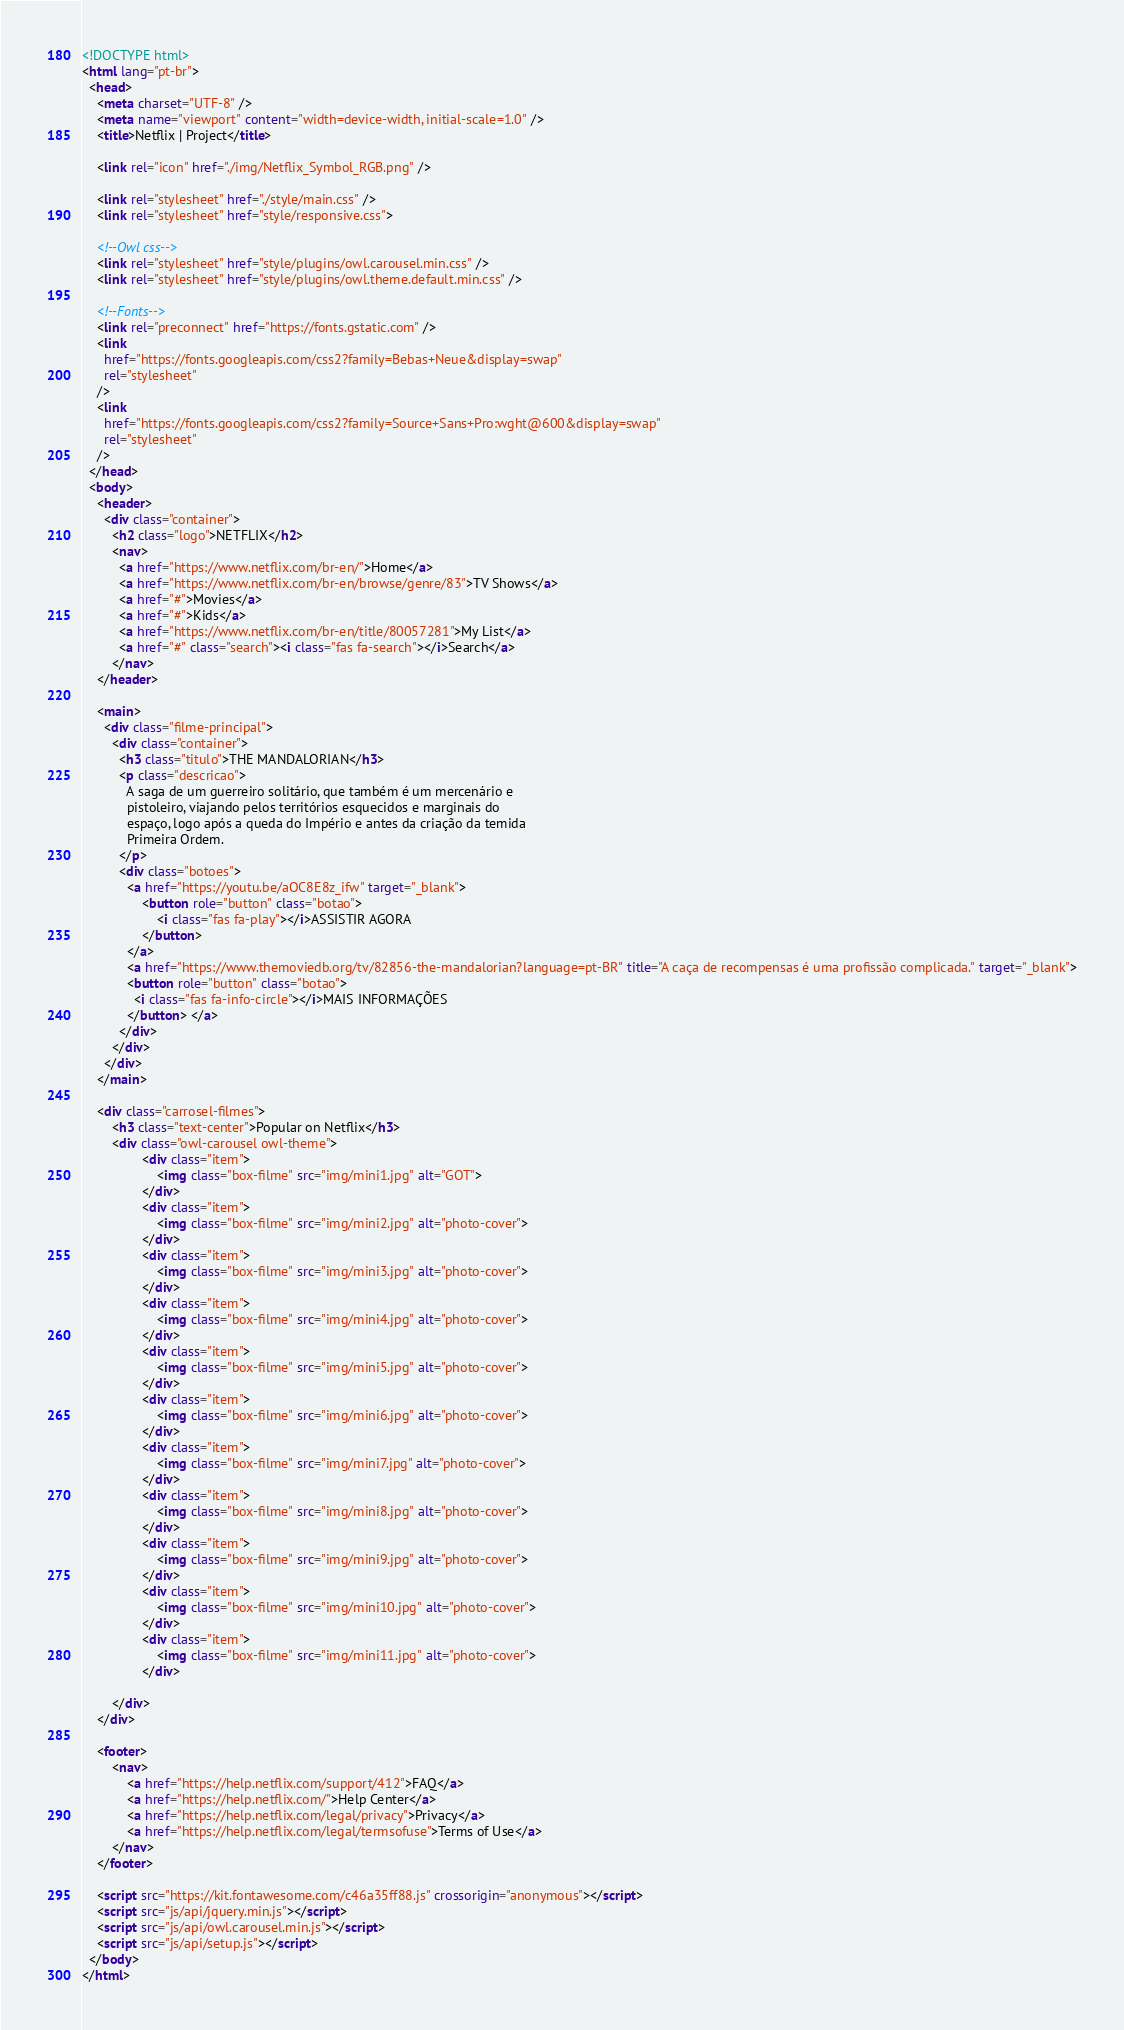Convert code to text. <code><loc_0><loc_0><loc_500><loc_500><_HTML_><!DOCTYPE html>
<html lang="pt-br">
  <head>
    <meta charset="UTF-8" />
    <meta name="viewport" content="width=device-width, initial-scale=1.0" />
    <title>Netflix | Project</title>

    <link rel="icon" href="./img/Netflix_Symbol_RGB.png" />

    <link rel="stylesheet" href="./style/main.css" />
    <link rel="stylesheet" href="style/responsive.css">

    <!--Owl css-->
    <link rel="stylesheet" href="style/plugins/owl.carousel.min.css" />
    <link rel="stylesheet" href="style/plugins/owl.theme.default.min.css" />

    <!--Fonts-->
    <link rel="preconnect" href="https://fonts.gstatic.com" />
    <link
      href="https://fonts.googleapis.com/css2?family=Bebas+Neue&display=swap"
      rel="stylesheet"
    />
    <link
      href="https://fonts.googleapis.com/css2?family=Source+Sans+Pro:wght@600&display=swap"
      rel="stylesheet"
    />
  </head>
  <body>
    <header>
      <div class="container">
        <h2 class="logo">NETFLIX</h2>
        <nav>
          <a href="https://www.netflix.com/br-en/">Home</a>
          <a href="https://www.netflix.com/br-en/browse/genre/83">TV Shows</a>
          <a href="#">Movies</a>
          <a href="#">Kids</a>
          <a href="https://www.netflix.com/br-en/title/80057281">My List</a>
          <a href="#" class="search"><i class="fas fa-search"></i>Search</a>
        </nav>
    </header>

    <main>
      <div class="filme-principal">
        <div class="container">
          <h3 class="titulo">THE MANDALORIAN</h3>
          <p class="descricao">
            A saga de um guerreiro solitário, que também é um mercenário e
            pistoleiro, viajando pelos territórios esquecidos e marginais do
            espaço, logo após a queda do Império e antes da criação da temida
            Primeira Ordem.
          </p>
          <div class="botoes">
            <a href="https://youtu.be/aOC8E8z_ifw" target="_blank">
                <button role="button" class="botao">
                    <i class="fas fa-play"></i>ASSISTIR AGORA
                </button> 
            </a>
            <a href="https://www.themoviedb.org/tv/82856-the-mandalorian?language=pt-BR" title="A caça de recompensas é uma profissão complicada." target="_blank">
            <button role="button" class="botao">
              <i class="fas fa-info-circle"></i>MAIS INFORMAÇÕES
            </button> </a>
          </div>
        </div>
      </div>
    </main>
    
    <div class="carrosel-filmes">
        <h3 class="text-center">Popular on Netflix</h3>
        <div class="owl-carousel owl-theme">
                <div class="item">
                    <img class="box-filme" src="img/mini1.jpg" alt="GOT">
                </div>
                <div class="item">
                    <img class="box-filme" src="img/mini2.jpg" alt="photo-cover">
                </div>
                <div class="item">
                    <img class="box-filme" src="img/mini3.jpg" alt="photo-cover">
                </div>
                <div class="item">
                    <img class="box-filme" src="img/mini4.jpg" alt="photo-cover">
                </div>
                <div class="item">
                    <img class="box-filme" src="img/mini5.jpg" alt="photo-cover">
                </div>
                <div class="item">
                    <img class="box-filme" src="img/mini6.jpg" alt="photo-cover">
                </div>
                <div class="item">
                    <img class="box-filme" src="img/mini7.jpg" alt="photo-cover">
                </div>
                <div class="item">
                    <img class="box-filme" src="img/mini8.jpg" alt="photo-cover">
                </div>
                <div class="item">
                    <img class="box-filme" src="img/mini9.jpg" alt="photo-cover">
                </div>
                <div class="item">
                    <img class="box-filme" src="img/mini10.jpg" alt="photo-cover">
                </div>
                <div class="item">
                    <img class="box-filme" src="img/mini11.jpg" alt="photo-cover">
                </div>

        </div>
    </div>

    <footer>
        <nav>
            <a href="https://help.netflix.com/support/412">FAQ</a>
            <a href="https://help.netflix.com/">Help Center</a>
            <a href="https://help.netflix.com/legal/privacy">Privacy</a>
            <a href="https://help.netflix.com/legal/termsofuse">Terms of Use</a>
        </nav>
    </footer>

    <script src="https://kit.fontawesome.com/c46a35ff88.js" crossorigin="anonymous"></script>
    <script src="js/api/jquery.min.js"></script>
    <script src="js/api/owl.carousel.min.js"></script>
    <script src="js/api/setup.js"></script>
  </body>
</html>
</code> 